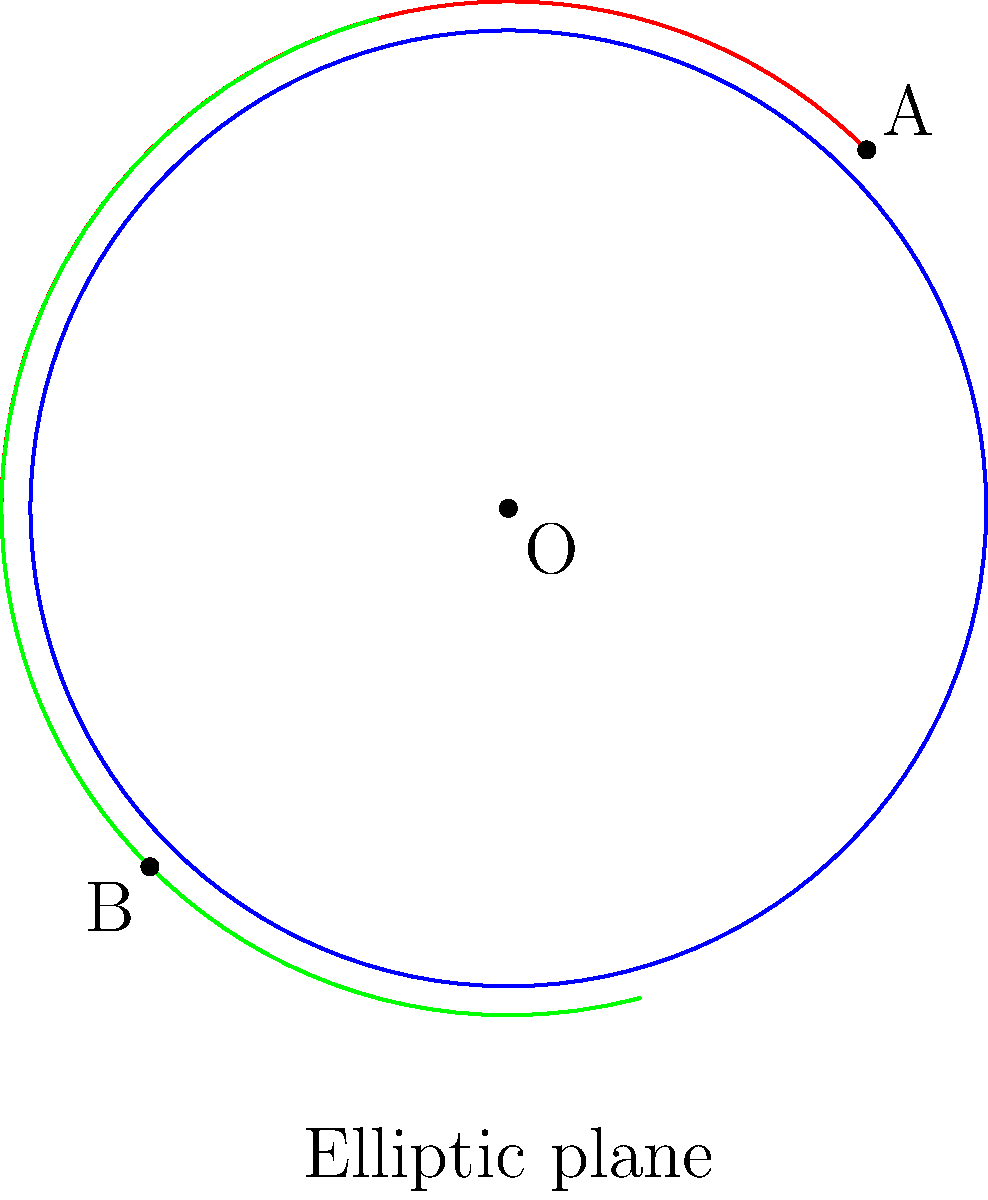In the context of elliptic geometry, as shown in the diagram, how do the red and green arcs (representing "straight lines" in this geometry) relate to each other? How does this differ from parallel lines in Euclidean geometry, and what implications might this have for a traveler exploring cultural sites with unique architectural features? To understand the relationship between the red and green arcs in elliptic geometry:

1. In elliptic geometry, "straight lines" are represented by great circles on a sphere, which appear as arcs in the 2D projection shown.

2. The red and green arcs both pass through antipodal points on the circle (sphere in 3D), representing the "equator" of this geometry.

3. Unlike parallel lines in Euclidean geometry, these "straight lines" in elliptic geometry intersect at two points (not shown in this 2D projection, but they would be on opposite sides of the sphere).

4. The concept of parallelism doesn't exist in elliptic geometry. All "straight lines" will eventually intersect.

5. The angle between these lines remains constant as you move along either line, unlike in Euclidean geometry where parallel lines maintain a constant distance.

6. For a traveler exploring cultural sites:
   a) This geometry could be found in dome-shaped structures or spherical architectural elements.
   b) It might influence the layout of circular cities or the design of panoramic viewing platforms.
   c) Understanding this geometry could enhance appreciation of how space is used in certain historical or modern architectural designs.

7. The fundamental difference is that in elliptic geometry, the sum of angles in a triangle is always greater than 180°, which could be observed in some architectural features or city layouts based on this geometric principle.
Answer: In elliptic geometry, the arcs intersect at two points, demonstrating no parallel lines exist, unlike Euclidean geometry. 